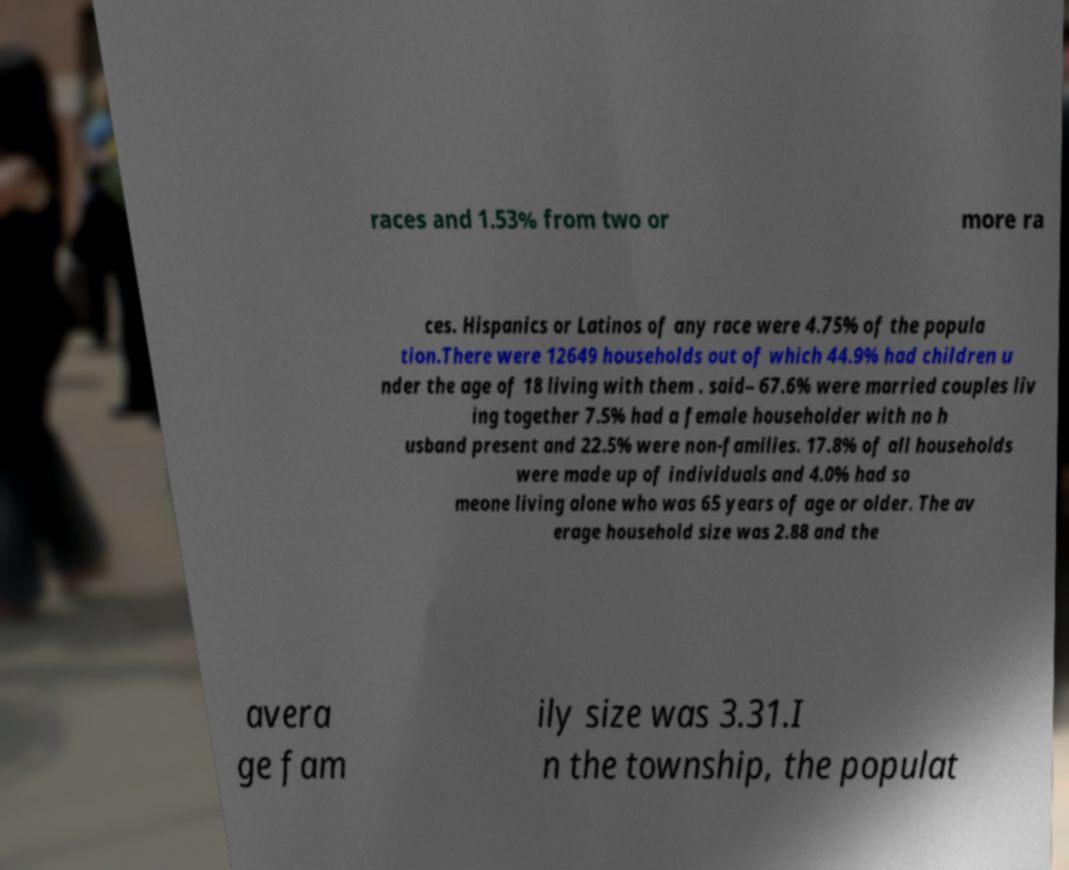What messages or text are displayed in this image? I need them in a readable, typed format. races and 1.53% from two or more ra ces. Hispanics or Latinos of any race were 4.75% of the popula tion.There were 12649 households out of which 44.9% had children u nder the age of 18 living with them . said– 67.6% were married couples liv ing together 7.5% had a female householder with no h usband present and 22.5% were non-families. 17.8% of all households were made up of individuals and 4.0% had so meone living alone who was 65 years of age or older. The av erage household size was 2.88 and the avera ge fam ily size was 3.31.I n the township, the populat 